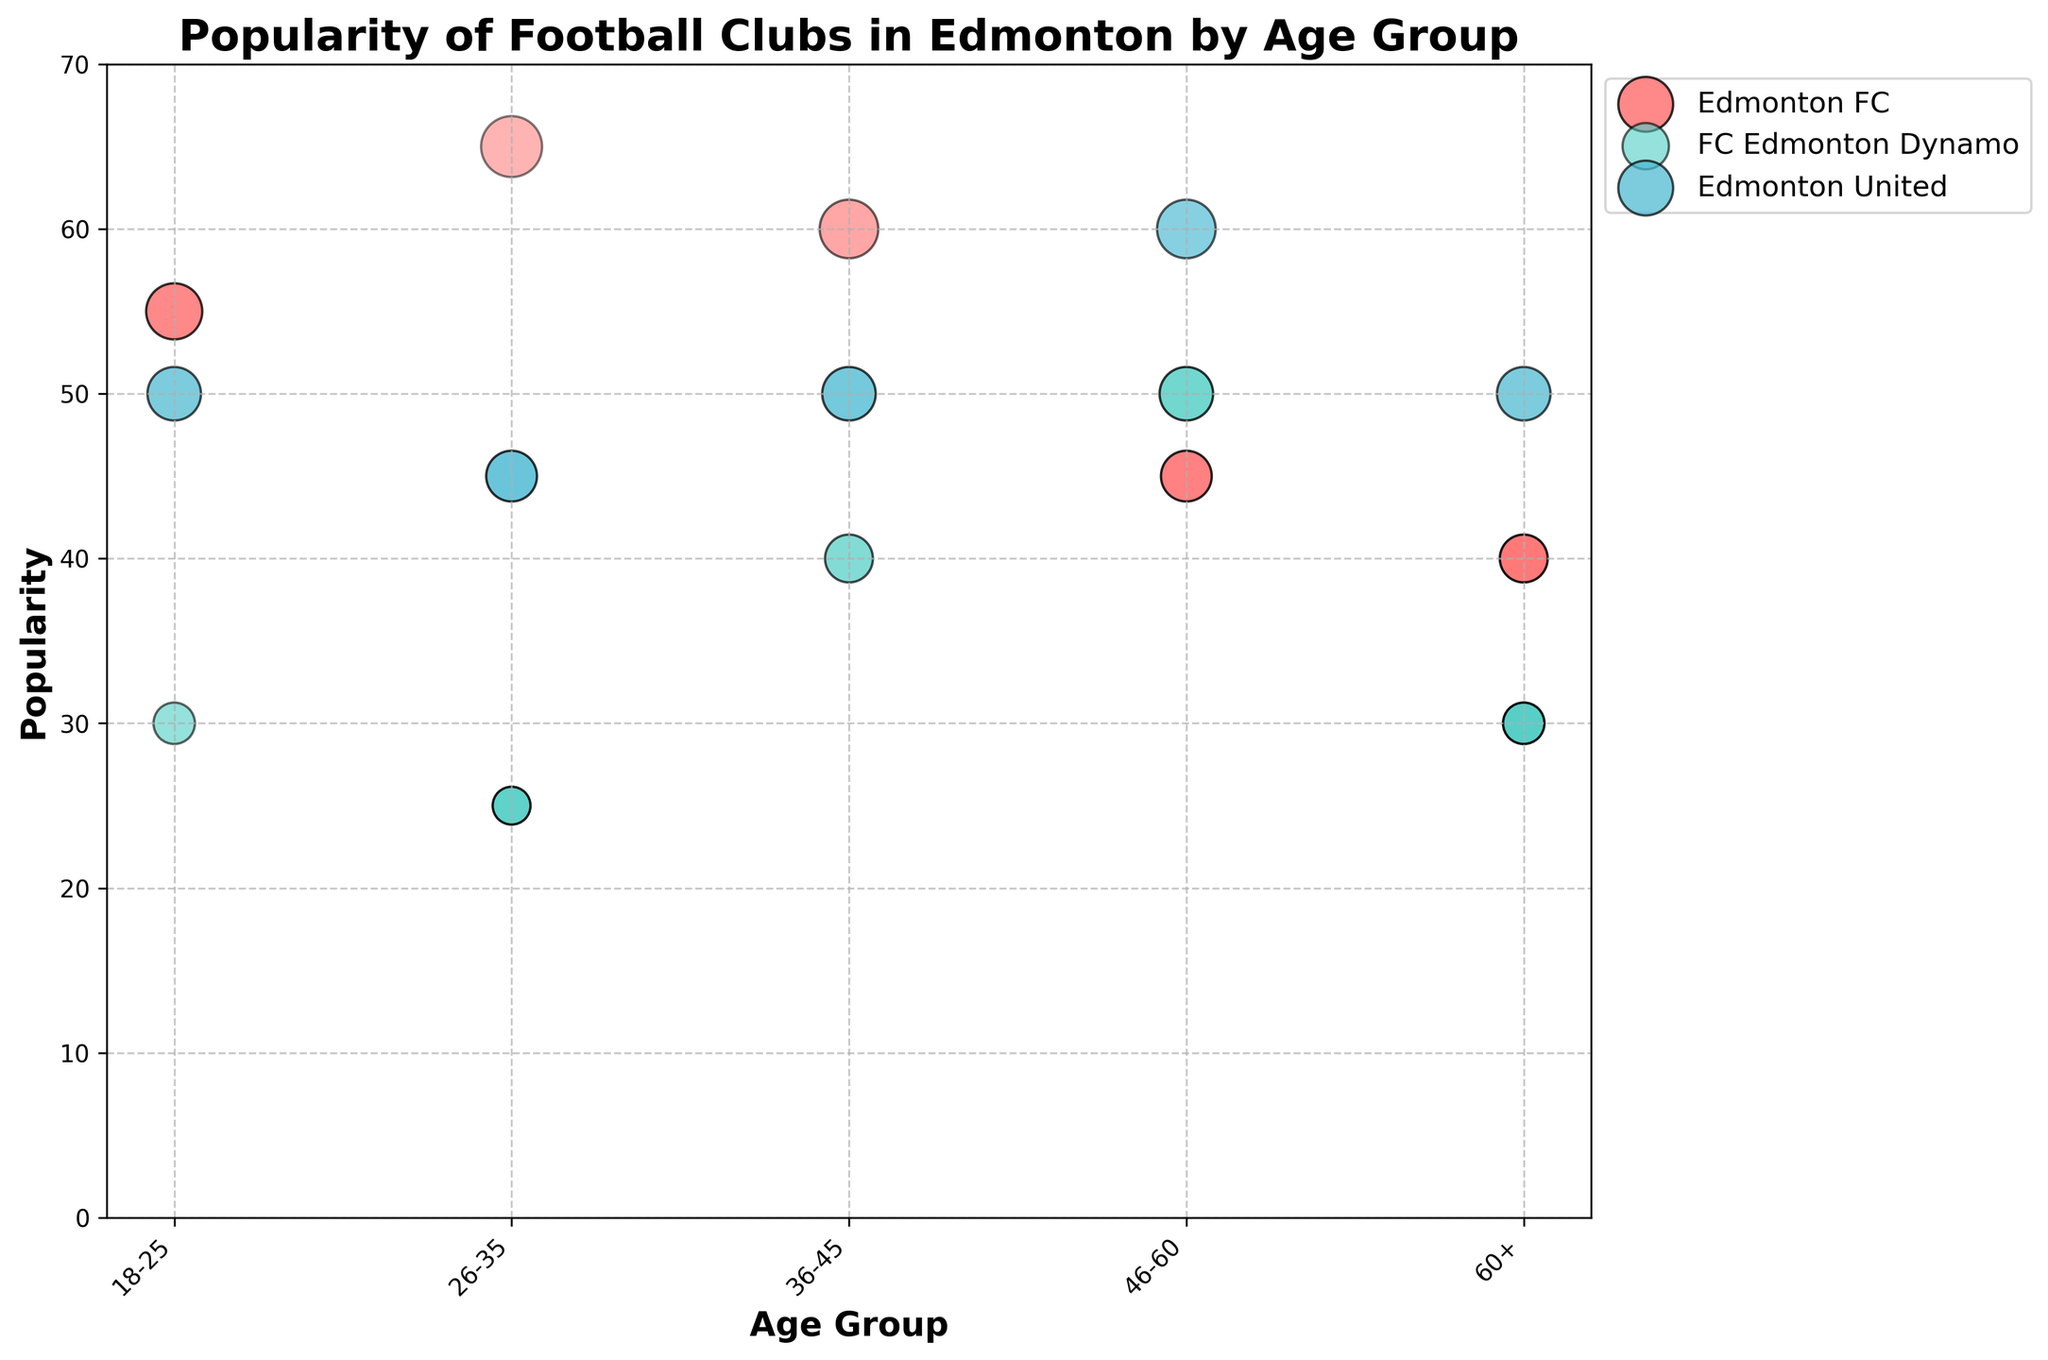What is the title of the chart? The title is located at the top of the chart and is written in bold.
Answer: Popularity of Football Clubs in Edmonton by Age Group How is the x-axis labeled? The label for the x-axis is found below the horizontal axis, indicating what the axis represents.
Answer: Age Group Which age group shows the highest popularity for Edmonton FC? By examining the bubbles corresponding to Edmonton FC, the position along the y-axis can help identify the highest value.
Answer: 26-35 In the age group 26-35, how does the popularity of Edmonton United compare to FC Edmonton Dynamo? Look at the vertical positions of the bubbles for Edmonton United and FC Edmonton Dynamo within the age group 26-35. Edmonton United has a higher bubble (indicating higher popularity) compared to FC Edmonton Dynamo.
Answer: Edmonton United is more popular than FC Edmonton Dynamo Which club has the most transparent bubble in the 60+ age group? Transparency is visually indicated by how see-through the bubbles are; the bubble with the highest transparency (highest opacity) corresponds to FC Edmonton Dynamo in the 60+ age group.
Answer: FC Edmonton Dynamo What is the average popularity of Edmonton United across all age groups? To calculate the average, sum up the popularity values of Edmonton United across all age groups and divide by the number of age groups: (50 + 45 + 50 + 60 + 50) / 5 = 51
Answer: 51 For the age group 18-25, which club has the smallest bubble and what does it indicate? The size of the bubble represents the popularity. The smallest bubble will be for the club with the lowest popularity.
Answer: FC Edmonton Dynamo has the smallest bubble What is the total popularity for Edmonton FC across the age groups 26-35 and 36-45? Sum the popularity values for Edmonton FC within the age groups 26-35 and 36-45: 65 (26-35) + 60 (36-45) = 125
Answer: 125 Which age group has the highest average popularity across all clubs? Calculate the average popularity for each age group by summing up the popularity values for all clubs within each group and dividing by the number of clubs, then compare these averages.
Answer: 26-35 How does the transparency of bubbles typically correspond to age groups? Compare the transparency levels across age groups by looking at the visual see-through level of bubbles. Generally, lower age groups have lower transparencies (less see-through), and higher age groups have higher transparencies (more see-through).
Answer: Higher age groups tend to have higher transparency 